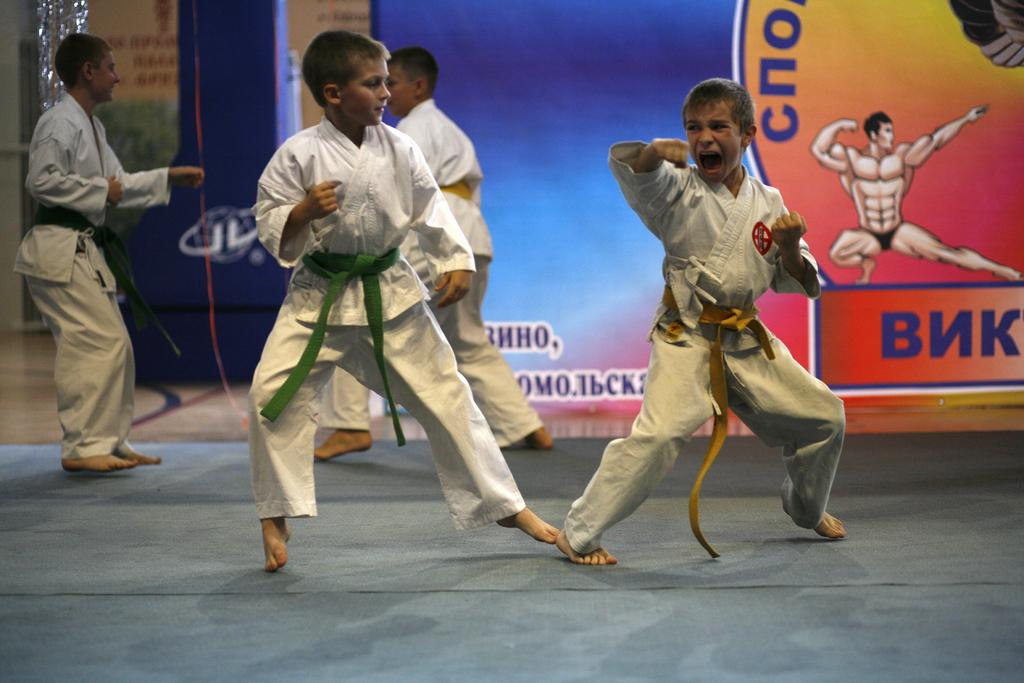How many children are in the image? There are four children in the image. What activity are the children engaged in? The children are practicing karate. Is there any additional information about the setting or context of the image? Yes, there is a background banner in the image. What type of truck is parked behind the children in the image? There is no truck visible in the image; it only features the four children practicing karate and a background banner. 